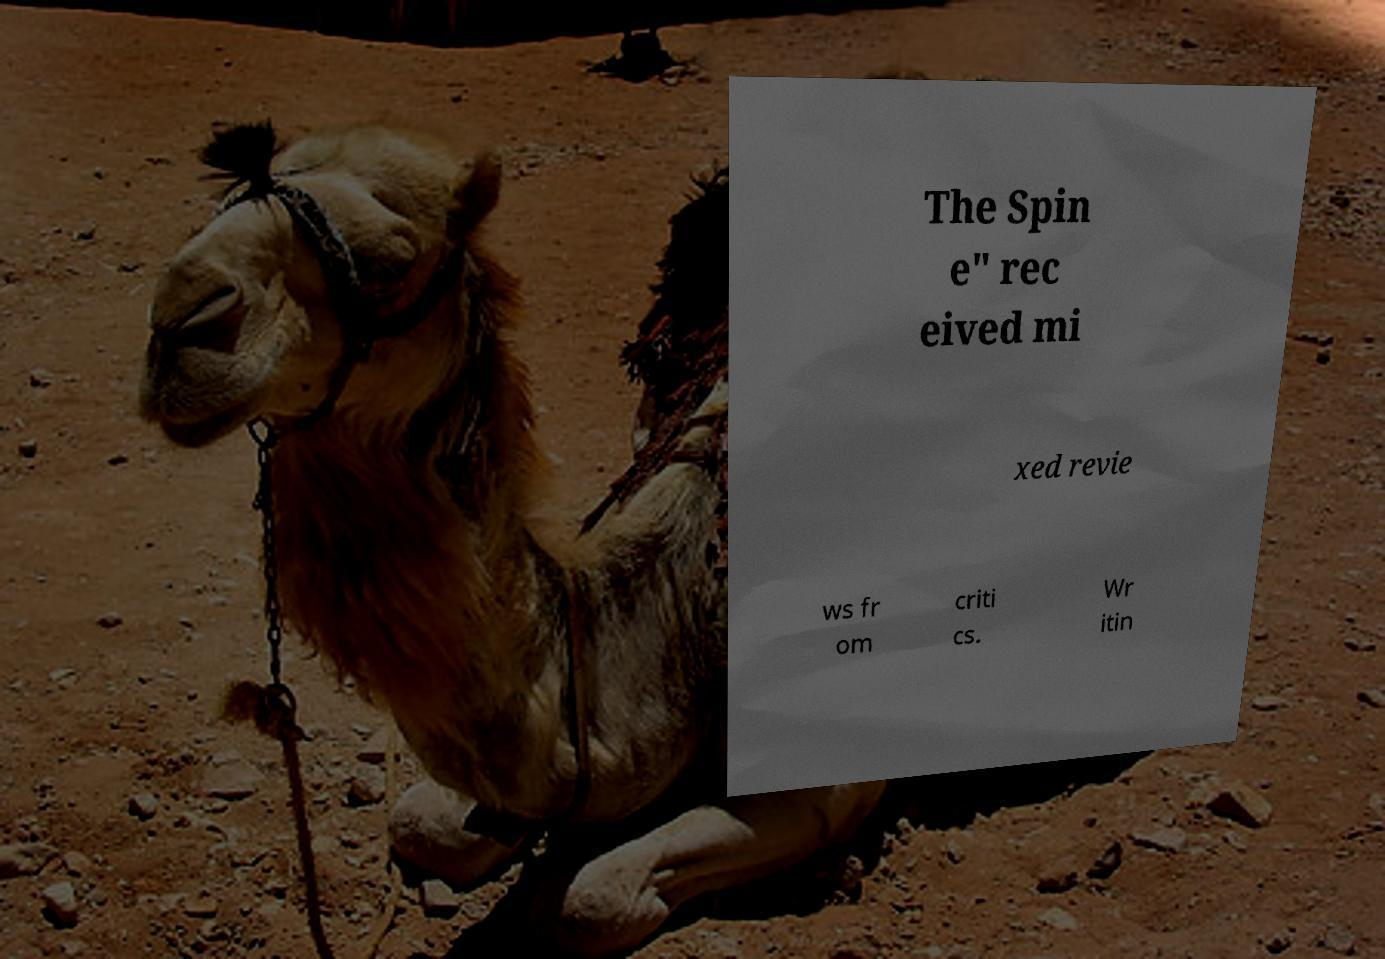Can you read and provide the text displayed in the image?This photo seems to have some interesting text. Can you extract and type it out for me? The Spin e" rec eived mi xed revie ws fr om criti cs. Wr itin 